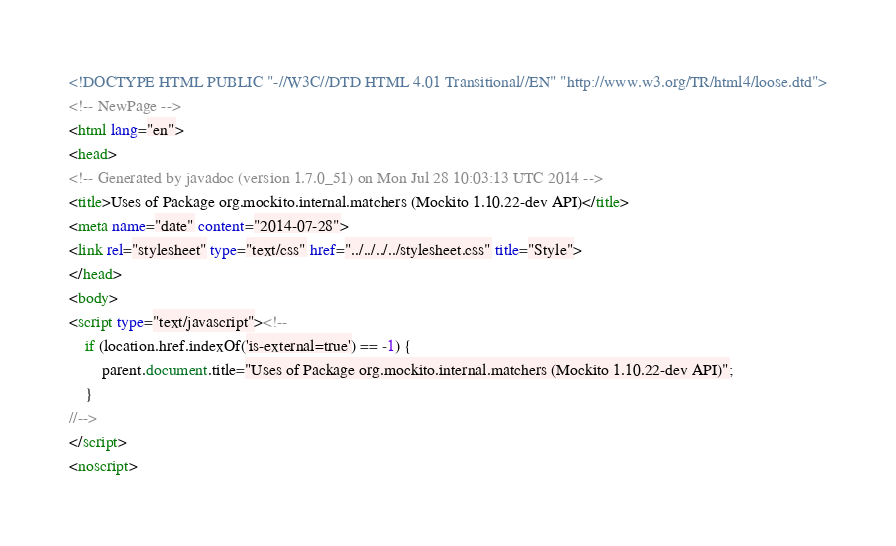<code> <loc_0><loc_0><loc_500><loc_500><_HTML_><!DOCTYPE HTML PUBLIC "-//W3C//DTD HTML 4.01 Transitional//EN" "http://www.w3.org/TR/html4/loose.dtd">
<!-- NewPage -->
<html lang="en">
<head>
<!-- Generated by javadoc (version 1.7.0_51) on Mon Jul 28 10:03:13 UTC 2014 -->
<title>Uses of Package org.mockito.internal.matchers (Mockito 1.10.22-dev API)</title>
<meta name="date" content="2014-07-28">
<link rel="stylesheet" type="text/css" href="../../../../stylesheet.css" title="Style">
</head>
<body>
<script type="text/javascript"><!--
    if (location.href.indexOf('is-external=true') == -1) {
        parent.document.title="Uses of Package org.mockito.internal.matchers (Mockito 1.10.22-dev API)";
    }
//-->
</script>
<noscript></code> 